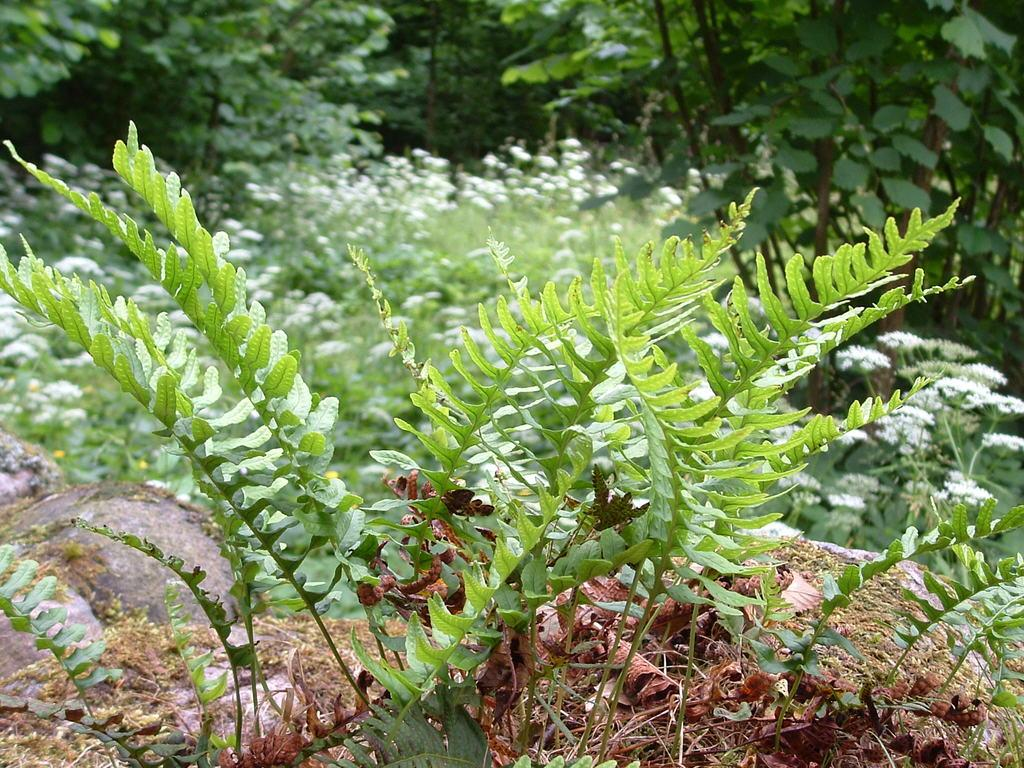What type of vegetation can be seen in the image? There are plants and trees in the image. Can you describe the specific types of plants or trees? The provided facts do not specify the types of plants or trees, so we cannot describe them in detail. How many girls are playing with the ball in the image? There are no girls or balls present in the image; it only features plants and trees. 